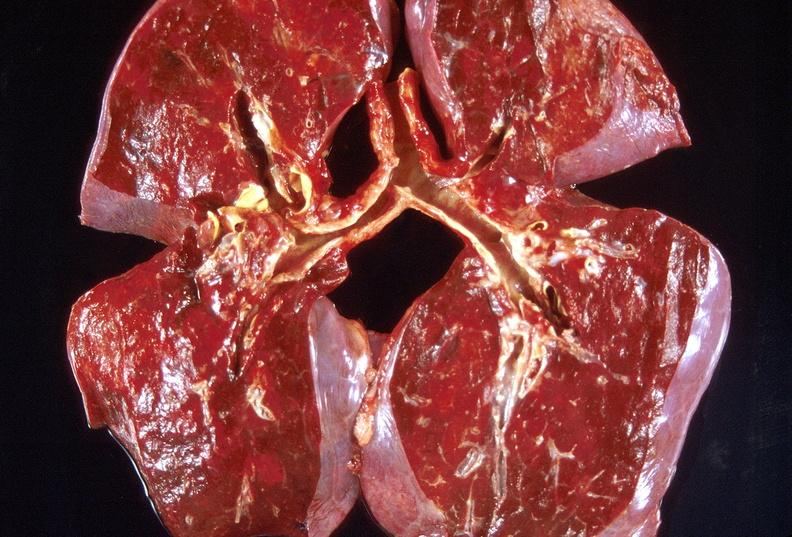where is this?
Answer the question using a single word or phrase. Lung 